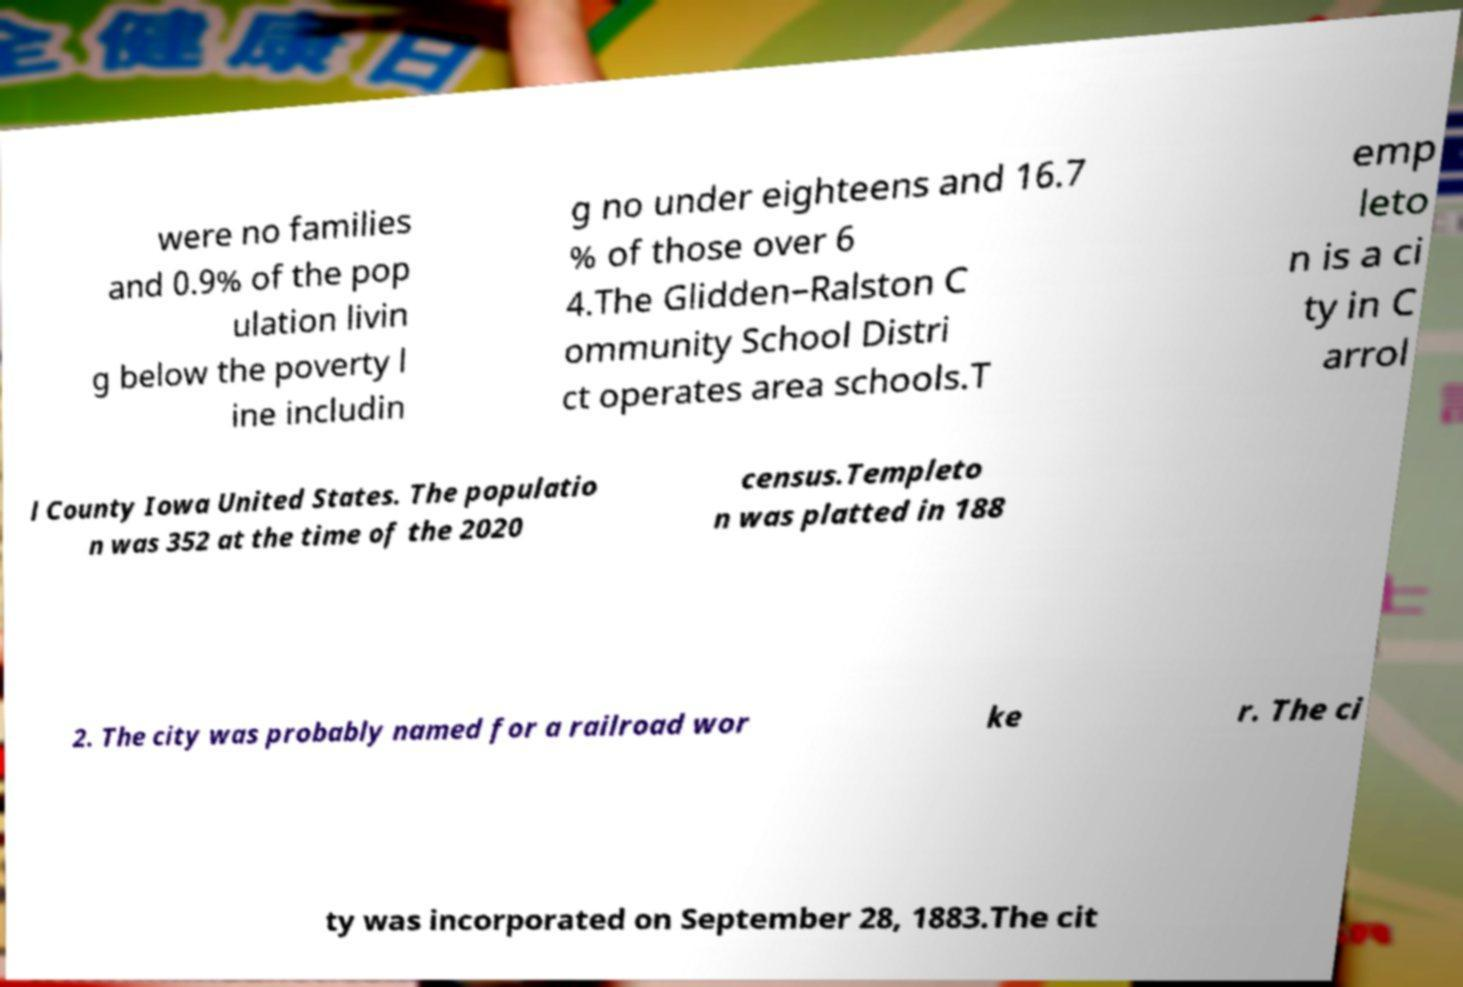What messages or text are displayed in this image? I need them in a readable, typed format. were no families and 0.9% of the pop ulation livin g below the poverty l ine includin g no under eighteens and 16.7 % of those over 6 4.The Glidden–Ralston C ommunity School Distri ct operates area schools.T emp leto n is a ci ty in C arrol l County Iowa United States. The populatio n was 352 at the time of the 2020 census.Templeto n was platted in 188 2. The city was probably named for a railroad wor ke r. The ci ty was incorporated on September 28, 1883.The cit 